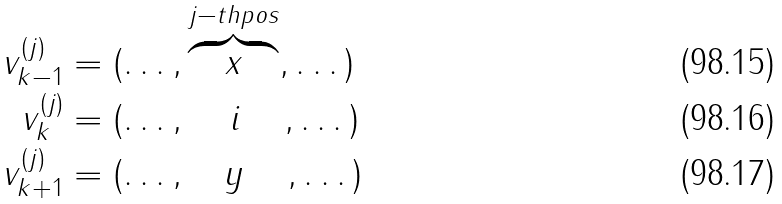Convert formula to latex. <formula><loc_0><loc_0><loc_500><loc_500>v _ { k - 1 } ^ { ( j ) } & = ( \dots , \overbrace { \quad x \quad } ^ { j - t h p o s } , \dots ) \\ v _ { k } ^ { ( j ) } & = ( \dots , \, \quad i \quad \, , \dots ) \\ v _ { k + 1 } ^ { ( j ) } & = ( \dots , \quad y \quad \, , \dots )</formula> 